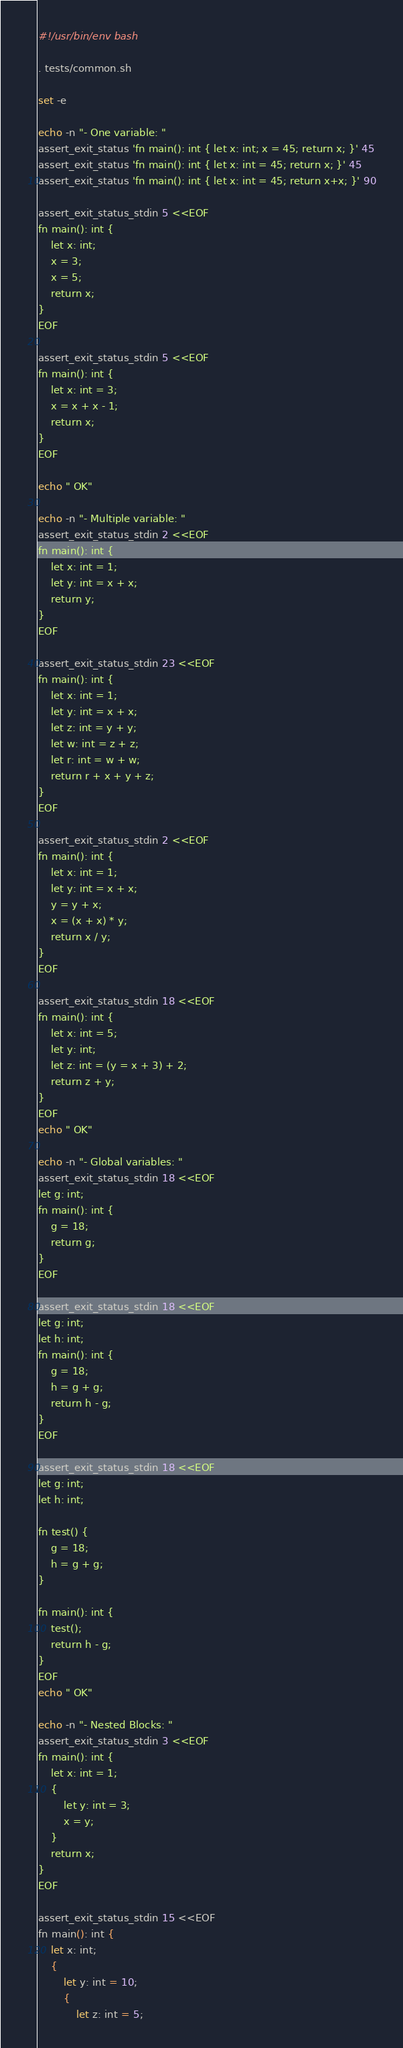Convert code to text. <code><loc_0><loc_0><loc_500><loc_500><_Bash_>#!/usr/bin/env bash

. tests/common.sh

set -e

echo -n "- One variable: "
assert_exit_status 'fn main(): int { let x: int; x = 45; return x; }' 45
assert_exit_status 'fn main(): int { let x: int = 45; return x; }' 45
assert_exit_status 'fn main(): int { let x: int = 45; return x+x; }' 90

assert_exit_status_stdin 5 <<EOF
fn main(): int {
    let x: int;
    x = 3;
    x = 5;
    return x;
}
EOF

assert_exit_status_stdin 5 <<EOF
fn main(): int {
    let x: int = 3;
    x = x + x - 1;
    return x;
}
EOF

echo " OK"

echo -n "- Multiple variable: "
assert_exit_status_stdin 2 <<EOF
fn main(): int {
    let x: int = 1;
    let y: int = x + x;
    return y;
}
EOF

assert_exit_status_stdin 23 <<EOF
fn main(): int {
    let x: int = 1;
    let y: int = x + x;
    let z: int = y + y;
    let w: int = z + z;
    let r: int = w + w;
    return r + x + y + z;
}
EOF

assert_exit_status_stdin 2 <<EOF
fn main(): int {
    let x: int = 1;
    let y: int = x + x;
    y = y + x;
    x = (x + x) * y;
    return x / y;
}
EOF

assert_exit_status_stdin 18 <<EOF
fn main(): int {
    let x: int = 5;
    let y: int;
    let z: int = (y = x + 3) + 2;
    return z + y;
}
EOF
echo " OK"

echo -n "- Global variables: "
assert_exit_status_stdin 18 <<EOF
let g: int;
fn main(): int {
    g = 18;
    return g;
}
EOF

assert_exit_status_stdin 18 <<EOF
let g: int;
let h: int;
fn main(): int {
    g = 18;
    h = g + g;
    return h - g;
}
EOF

assert_exit_status_stdin 18 <<EOF
let g: int;
let h: int;

fn test() {
    g = 18;
    h = g + g;
}

fn main(): int {
    test();
    return h - g;
}
EOF
echo " OK"

echo -n "- Nested Blocks: "
assert_exit_status_stdin 3 <<EOF
fn main(): int {
    let x: int = 1;
    {
        let y: int = 3;
        x = y;
    }
    return x;
}
EOF

assert_exit_status_stdin 15 <<EOF
fn main(): int {
    let x: int;
    {
        let y: int = 10;
        {
            let z: int = 5;</code> 